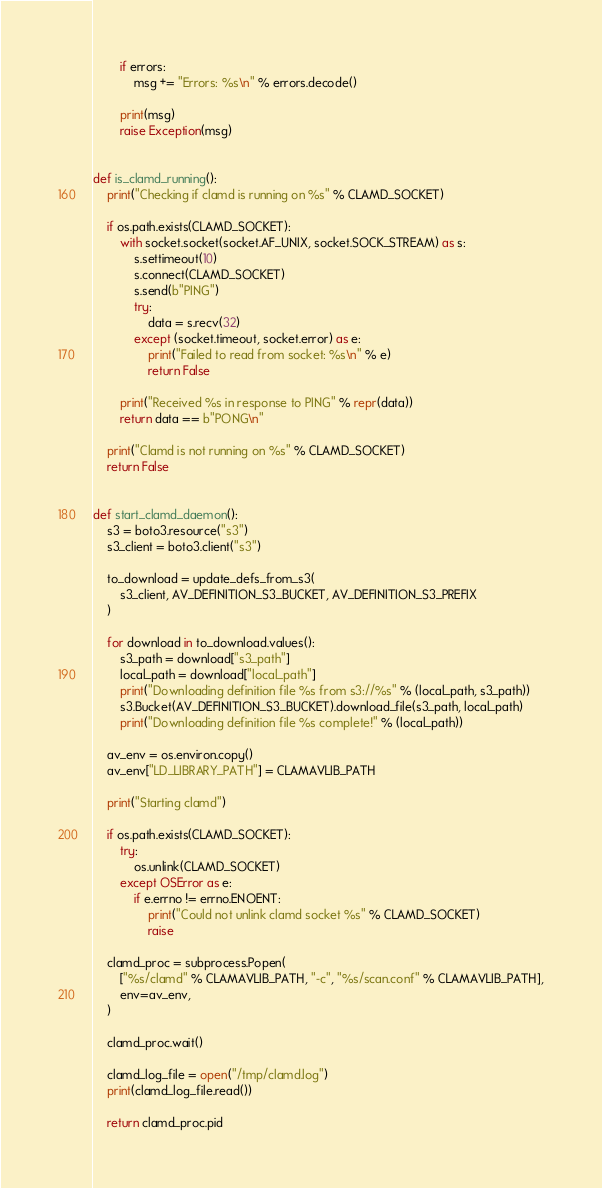Convert code to text. <code><loc_0><loc_0><loc_500><loc_500><_Python_>        if errors:
            msg += "Errors: %s\n" % errors.decode()

        print(msg)
        raise Exception(msg)


def is_clamd_running():
    print("Checking if clamd is running on %s" % CLAMD_SOCKET)

    if os.path.exists(CLAMD_SOCKET):
        with socket.socket(socket.AF_UNIX, socket.SOCK_STREAM) as s:
            s.settimeout(10)
            s.connect(CLAMD_SOCKET)
            s.send(b"PING")
            try:
                data = s.recv(32)
            except (socket.timeout, socket.error) as e:
                print("Failed to read from socket: %s\n" % e)
                return False

        print("Received %s in response to PING" % repr(data))
        return data == b"PONG\n"

    print("Clamd is not running on %s" % CLAMD_SOCKET)
    return False


def start_clamd_daemon():
    s3 = boto3.resource("s3")
    s3_client = boto3.client("s3")

    to_download = update_defs_from_s3(
        s3_client, AV_DEFINITION_S3_BUCKET, AV_DEFINITION_S3_PREFIX
    )

    for download in to_download.values():
        s3_path = download["s3_path"]
        local_path = download["local_path"]
        print("Downloading definition file %s from s3://%s" % (local_path, s3_path))
        s3.Bucket(AV_DEFINITION_S3_BUCKET).download_file(s3_path, local_path)
        print("Downloading definition file %s complete!" % (local_path))

    av_env = os.environ.copy()
    av_env["LD_LIBRARY_PATH"] = CLAMAVLIB_PATH

    print("Starting clamd")

    if os.path.exists(CLAMD_SOCKET):
        try:
            os.unlink(CLAMD_SOCKET)
        except OSError as e:
            if e.errno != errno.ENOENT:
                print("Could not unlink clamd socket %s" % CLAMD_SOCKET)
                raise

    clamd_proc = subprocess.Popen(
        ["%s/clamd" % CLAMAVLIB_PATH, "-c", "%s/scan.conf" % CLAMAVLIB_PATH],
        env=av_env,
    )

    clamd_proc.wait()

    clamd_log_file = open("/tmp/clamd.log")
    print(clamd_log_file.read())

    return clamd_proc.pid
</code> 